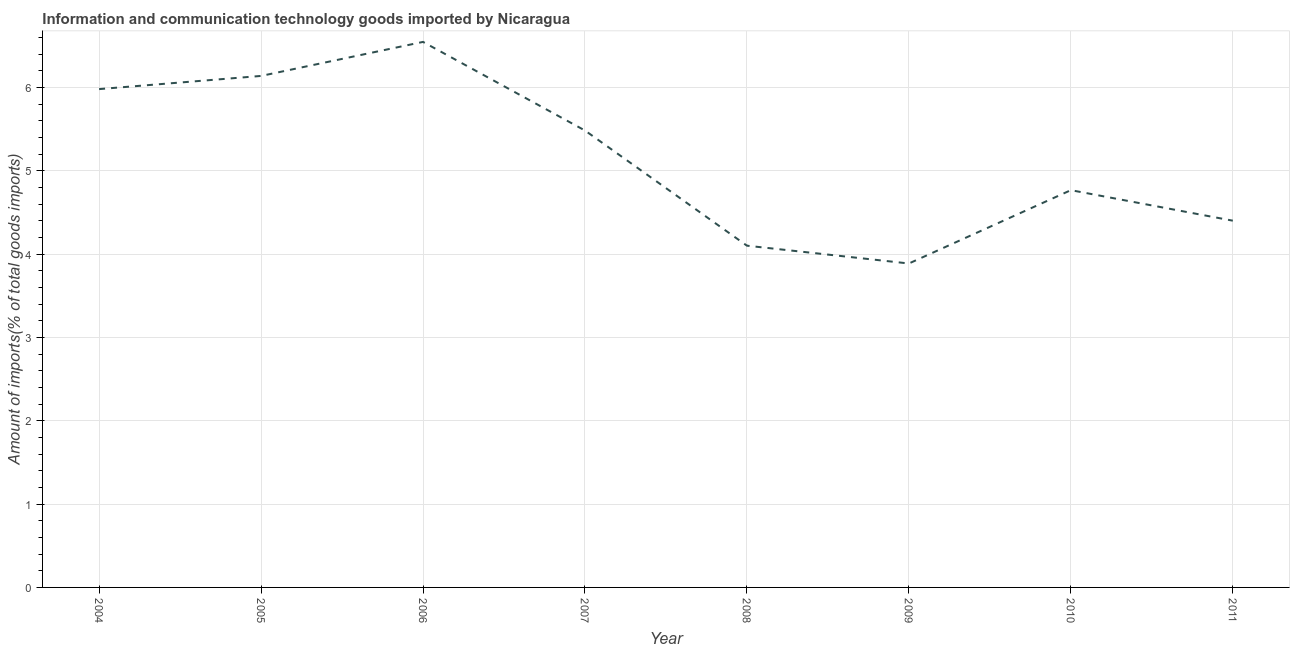What is the amount of ict goods imports in 2005?
Make the answer very short. 6.14. Across all years, what is the maximum amount of ict goods imports?
Ensure brevity in your answer.  6.55. Across all years, what is the minimum amount of ict goods imports?
Give a very brief answer. 3.89. In which year was the amount of ict goods imports maximum?
Your answer should be compact. 2006. What is the sum of the amount of ict goods imports?
Keep it short and to the point. 41.3. What is the difference between the amount of ict goods imports in 2004 and 2011?
Provide a short and direct response. 1.58. What is the average amount of ict goods imports per year?
Provide a succinct answer. 5.16. What is the median amount of ict goods imports?
Provide a short and direct response. 5.13. Do a majority of the years between 2009 and 2011 (inclusive) have amount of ict goods imports greater than 1.8 %?
Your answer should be compact. Yes. What is the ratio of the amount of ict goods imports in 2006 to that in 2008?
Provide a succinct answer. 1.6. Is the amount of ict goods imports in 2007 less than that in 2010?
Your response must be concise. No. Is the difference between the amount of ict goods imports in 2005 and 2009 greater than the difference between any two years?
Offer a very short reply. No. What is the difference between the highest and the second highest amount of ict goods imports?
Your response must be concise. 0.41. Is the sum of the amount of ict goods imports in 2006 and 2007 greater than the maximum amount of ict goods imports across all years?
Your answer should be very brief. Yes. What is the difference between the highest and the lowest amount of ict goods imports?
Give a very brief answer. 2.66. In how many years, is the amount of ict goods imports greater than the average amount of ict goods imports taken over all years?
Offer a terse response. 4. Does the amount of ict goods imports monotonically increase over the years?
Keep it short and to the point. No. How many lines are there?
Offer a terse response. 1. What is the difference between two consecutive major ticks on the Y-axis?
Make the answer very short. 1. Are the values on the major ticks of Y-axis written in scientific E-notation?
Your answer should be very brief. No. Does the graph contain any zero values?
Your answer should be very brief. No. Does the graph contain grids?
Ensure brevity in your answer.  Yes. What is the title of the graph?
Ensure brevity in your answer.  Information and communication technology goods imported by Nicaragua. What is the label or title of the Y-axis?
Give a very brief answer. Amount of imports(% of total goods imports). What is the Amount of imports(% of total goods imports) of 2004?
Your answer should be compact. 5.98. What is the Amount of imports(% of total goods imports) in 2005?
Give a very brief answer. 6.14. What is the Amount of imports(% of total goods imports) of 2006?
Your response must be concise. 6.55. What is the Amount of imports(% of total goods imports) of 2007?
Your answer should be compact. 5.48. What is the Amount of imports(% of total goods imports) of 2008?
Ensure brevity in your answer.  4.1. What is the Amount of imports(% of total goods imports) in 2009?
Your answer should be very brief. 3.89. What is the Amount of imports(% of total goods imports) of 2010?
Provide a succinct answer. 4.77. What is the Amount of imports(% of total goods imports) in 2011?
Offer a very short reply. 4.4. What is the difference between the Amount of imports(% of total goods imports) in 2004 and 2005?
Keep it short and to the point. -0.16. What is the difference between the Amount of imports(% of total goods imports) in 2004 and 2006?
Offer a terse response. -0.57. What is the difference between the Amount of imports(% of total goods imports) in 2004 and 2007?
Ensure brevity in your answer.  0.5. What is the difference between the Amount of imports(% of total goods imports) in 2004 and 2008?
Your response must be concise. 1.88. What is the difference between the Amount of imports(% of total goods imports) in 2004 and 2009?
Provide a succinct answer. 2.09. What is the difference between the Amount of imports(% of total goods imports) in 2004 and 2010?
Offer a very short reply. 1.21. What is the difference between the Amount of imports(% of total goods imports) in 2004 and 2011?
Make the answer very short. 1.58. What is the difference between the Amount of imports(% of total goods imports) in 2005 and 2006?
Offer a very short reply. -0.41. What is the difference between the Amount of imports(% of total goods imports) in 2005 and 2007?
Ensure brevity in your answer.  0.66. What is the difference between the Amount of imports(% of total goods imports) in 2005 and 2008?
Make the answer very short. 2.04. What is the difference between the Amount of imports(% of total goods imports) in 2005 and 2009?
Make the answer very short. 2.25. What is the difference between the Amount of imports(% of total goods imports) in 2005 and 2010?
Your answer should be compact. 1.37. What is the difference between the Amount of imports(% of total goods imports) in 2005 and 2011?
Provide a succinct answer. 1.74. What is the difference between the Amount of imports(% of total goods imports) in 2006 and 2007?
Provide a short and direct response. 1.06. What is the difference between the Amount of imports(% of total goods imports) in 2006 and 2008?
Make the answer very short. 2.45. What is the difference between the Amount of imports(% of total goods imports) in 2006 and 2009?
Give a very brief answer. 2.66. What is the difference between the Amount of imports(% of total goods imports) in 2006 and 2010?
Offer a terse response. 1.78. What is the difference between the Amount of imports(% of total goods imports) in 2006 and 2011?
Your answer should be compact. 2.15. What is the difference between the Amount of imports(% of total goods imports) in 2007 and 2008?
Make the answer very short. 1.38. What is the difference between the Amount of imports(% of total goods imports) in 2007 and 2009?
Make the answer very short. 1.6. What is the difference between the Amount of imports(% of total goods imports) in 2007 and 2010?
Your answer should be very brief. 0.72. What is the difference between the Amount of imports(% of total goods imports) in 2007 and 2011?
Offer a terse response. 1.08. What is the difference between the Amount of imports(% of total goods imports) in 2008 and 2009?
Offer a very short reply. 0.21. What is the difference between the Amount of imports(% of total goods imports) in 2008 and 2010?
Your answer should be compact. -0.67. What is the difference between the Amount of imports(% of total goods imports) in 2008 and 2011?
Your response must be concise. -0.3. What is the difference between the Amount of imports(% of total goods imports) in 2009 and 2010?
Your answer should be compact. -0.88. What is the difference between the Amount of imports(% of total goods imports) in 2009 and 2011?
Offer a terse response. -0.51. What is the difference between the Amount of imports(% of total goods imports) in 2010 and 2011?
Ensure brevity in your answer.  0.37. What is the ratio of the Amount of imports(% of total goods imports) in 2004 to that in 2006?
Make the answer very short. 0.91. What is the ratio of the Amount of imports(% of total goods imports) in 2004 to that in 2007?
Make the answer very short. 1.09. What is the ratio of the Amount of imports(% of total goods imports) in 2004 to that in 2008?
Offer a terse response. 1.46. What is the ratio of the Amount of imports(% of total goods imports) in 2004 to that in 2009?
Provide a succinct answer. 1.54. What is the ratio of the Amount of imports(% of total goods imports) in 2004 to that in 2010?
Keep it short and to the point. 1.25. What is the ratio of the Amount of imports(% of total goods imports) in 2004 to that in 2011?
Your answer should be very brief. 1.36. What is the ratio of the Amount of imports(% of total goods imports) in 2005 to that in 2006?
Provide a succinct answer. 0.94. What is the ratio of the Amount of imports(% of total goods imports) in 2005 to that in 2007?
Provide a short and direct response. 1.12. What is the ratio of the Amount of imports(% of total goods imports) in 2005 to that in 2008?
Your response must be concise. 1.5. What is the ratio of the Amount of imports(% of total goods imports) in 2005 to that in 2009?
Provide a succinct answer. 1.58. What is the ratio of the Amount of imports(% of total goods imports) in 2005 to that in 2010?
Offer a terse response. 1.29. What is the ratio of the Amount of imports(% of total goods imports) in 2005 to that in 2011?
Keep it short and to the point. 1.4. What is the ratio of the Amount of imports(% of total goods imports) in 2006 to that in 2007?
Make the answer very short. 1.19. What is the ratio of the Amount of imports(% of total goods imports) in 2006 to that in 2008?
Offer a terse response. 1.6. What is the ratio of the Amount of imports(% of total goods imports) in 2006 to that in 2009?
Provide a succinct answer. 1.68. What is the ratio of the Amount of imports(% of total goods imports) in 2006 to that in 2010?
Provide a short and direct response. 1.37. What is the ratio of the Amount of imports(% of total goods imports) in 2006 to that in 2011?
Your response must be concise. 1.49. What is the ratio of the Amount of imports(% of total goods imports) in 2007 to that in 2008?
Your answer should be very brief. 1.34. What is the ratio of the Amount of imports(% of total goods imports) in 2007 to that in 2009?
Give a very brief answer. 1.41. What is the ratio of the Amount of imports(% of total goods imports) in 2007 to that in 2010?
Ensure brevity in your answer.  1.15. What is the ratio of the Amount of imports(% of total goods imports) in 2007 to that in 2011?
Your answer should be compact. 1.25. What is the ratio of the Amount of imports(% of total goods imports) in 2008 to that in 2009?
Keep it short and to the point. 1.05. What is the ratio of the Amount of imports(% of total goods imports) in 2008 to that in 2010?
Offer a very short reply. 0.86. What is the ratio of the Amount of imports(% of total goods imports) in 2008 to that in 2011?
Your answer should be compact. 0.93. What is the ratio of the Amount of imports(% of total goods imports) in 2009 to that in 2010?
Offer a very short reply. 0.81. What is the ratio of the Amount of imports(% of total goods imports) in 2009 to that in 2011?
Give a very brief answer. 0.88. What is the ratio of the Amount of imports(% of total goods imports) in 2010 to that in 2011?
Ensure brevity in your answer.  1.08. 